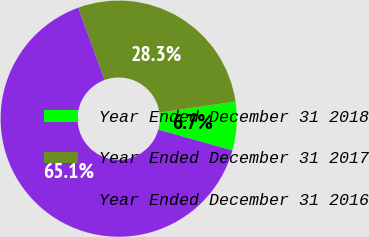Convert chart to OTSL. <chart><loc_0><loc_0><loc_500><loc_500><pie_chart><fcel>Year Ended December 31 2018<fcel>Year Ended December 31 2017<fcel>Year Ended December 31 2016<nl><fcel>6.65%<fcel>28.26%<fcel>65.09%<nl></chart> 